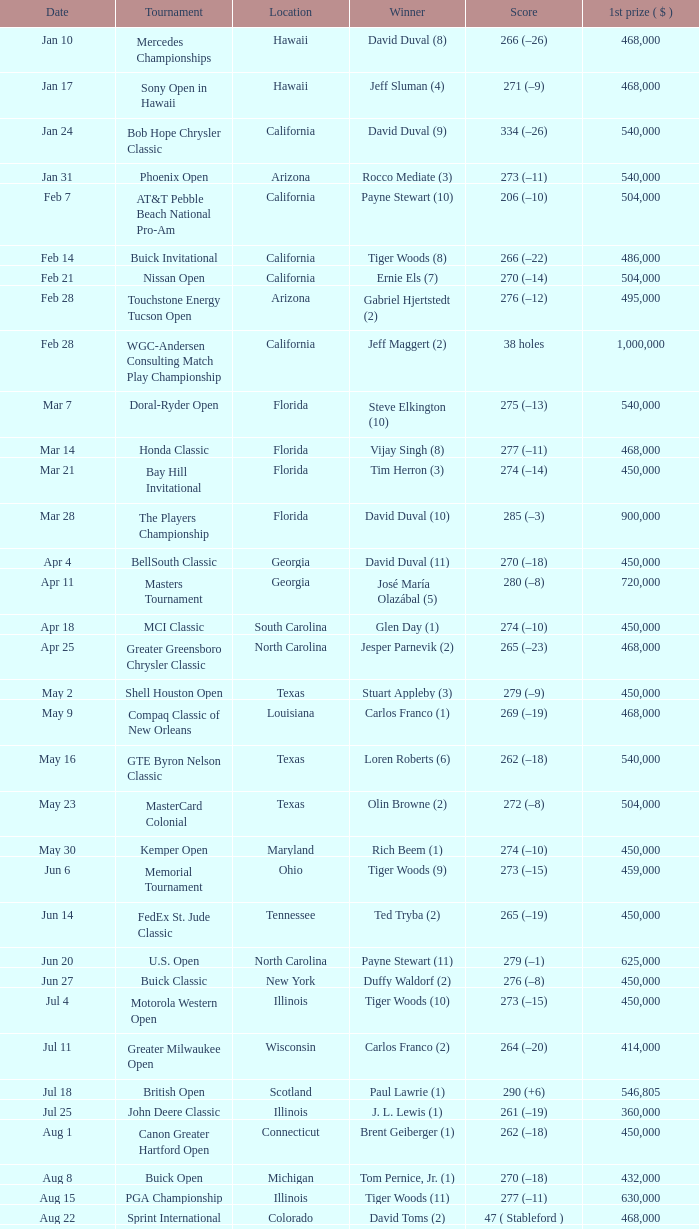When does the greater greensboro chrysler classic take place? Apr 25. 